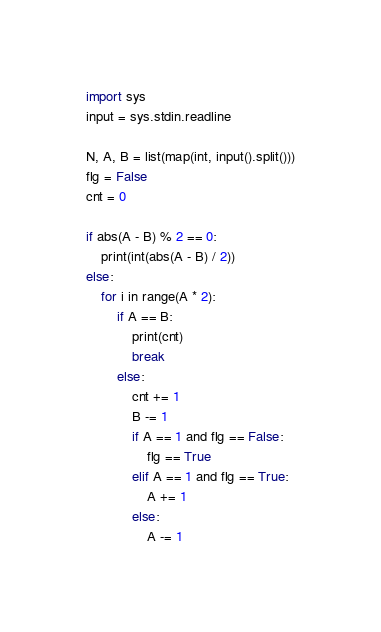<code> <loc_0><loc_0><loc_500><loc_500><_Python_>import sys
input = sys.stdin.readline

N, A, B = list(map(int, input().split()))
flg = False
cnt = 0

if abs(A - B) % 2 == 0:
    print(int(abs(A - B) / 2))
else:
    for i in range(A * 2):
        if A == B:
            print(cnt)
            break
        else:
            cnt += 1
            B -= 1
            if A == 1 and flg == False:
                flg == True
            elif A == 1 and flg == True:
                A += 1
            else:
                A -= 1
</code> 